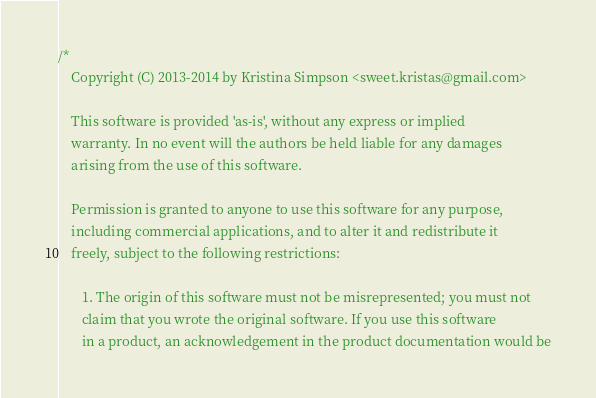<code> <loc_0><loc_0><loc_500><loc_500><_C++_>/*
	Copyright (C) 2013-2014 by Kristina Simpson <sweet.kristas@gmail.com>
	
	This software is provided 'as-is', without any express or implied
	warranty. In no event will the authors be held liable for any damages
	arising from the use of this software.

	Permission is granted to anyone to use this software for any purpose,
	including commercial applications, and to alter it and redistribute it
	freely, subject to the following restrictions:

	   1. The origin of this software must not be misrepresented; you must not
	   claim that you wrote the original software. If you use this software
	   in a product, an acknowledgement in the product documentation would be</code> 